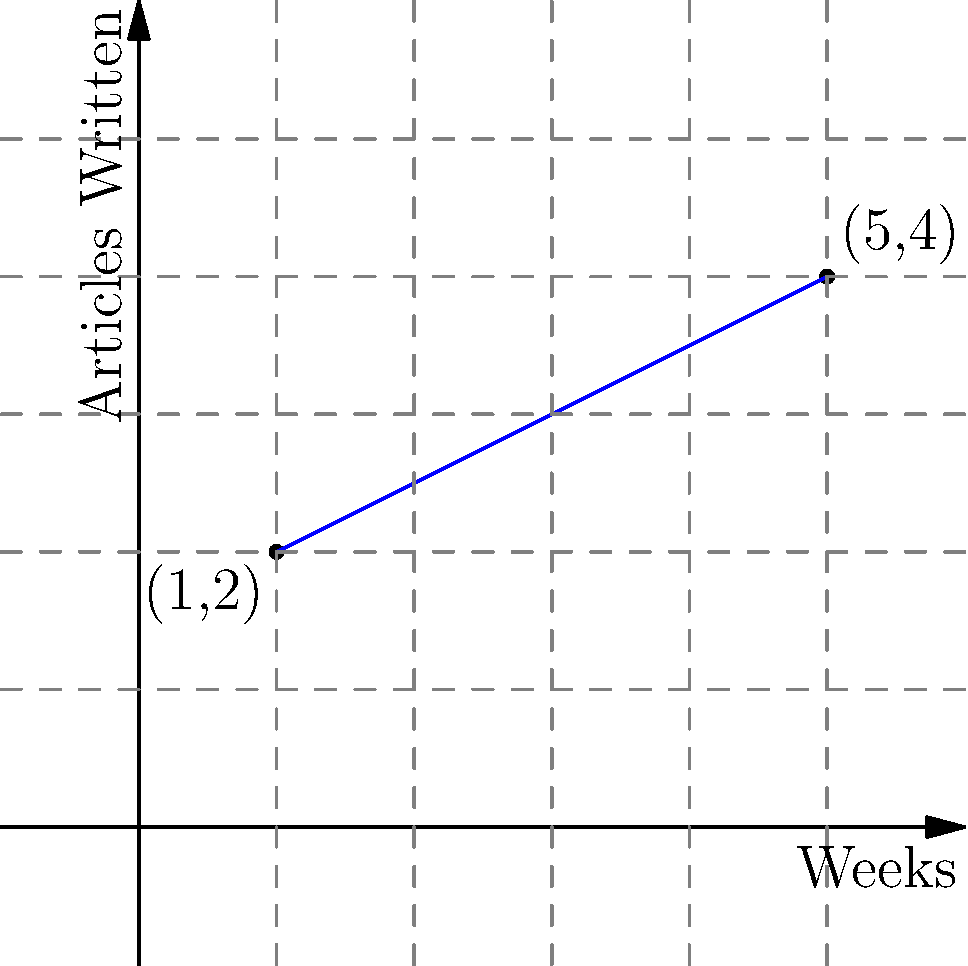A freelance writer tracks their productivity over time. The graph shows the number of articles written in relation to the number of weeks. Point A (1,2) represents 2 articles written after 1 week, and point B (5,4) represents 4 articles written after 5 weeks. Find the equation of the line representing the writer's productivity trend, expressing it in slope-intercept form $(y = mx + b)$. To find the equation of the line in slope-intercept form $(y = mx + b)$, we need to calculate the slope $(m)$ and y-intercept $(b)$. Let's follow these steps:

1. Calculate the slope $(m)$ using the two given points:
   $m = \frac{y_2 - y_1}{x_2 - x_1} = \frac{4 - 2}{5 - 1} = \frac{2}{4} = \frac{1}{2}$

2. Use the point-slope form of a line with either point. Let's use (1,2):
   $y - y_1 = m(x - x_1)$
   $y - 2 = \frac{1}{2}(x - 1)$

3. Expand the equation:
   $y - 2 = \frac{1}{2}x - \frac{1}{2}$

4. Solve for $y$ to get the slope-intercept form:
   $y = \frac{1}{2}x - \frac{1}{2} + 2$
   $y = \frac{1}{2}x + \frac{3}{2}$

Therefore, the equation of the line representing the writer's productivity trend is $y = \frac{1}{2}x + \frac{3}{2}$.
Answer: $y = \frac{1}{2}x + \frac{3}{2}$ 